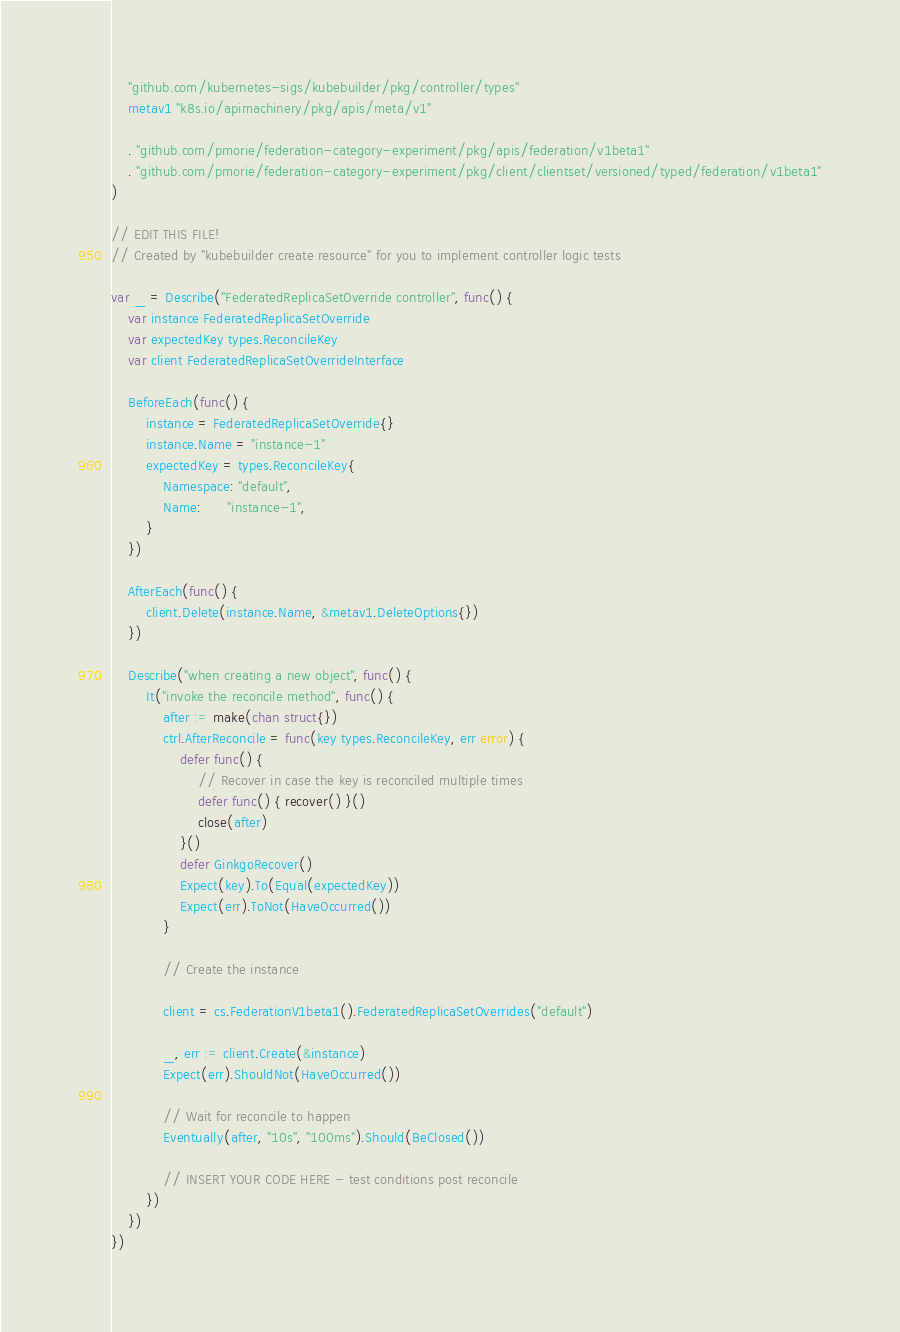Convert code to text. <code><loc_0><loc_0><loc_500><loc_500><_Go_>	"github.com/kubernetes-sigs/kubebuilder/pkg/controller/types"
	metav1 "k8s.io/apimachinery/pkg/apis/meta/v1"

	. "github.com/pmorie/federation-category-experiment/pkg/apis/federation/v1beta1"
	. "github.com/pmorie/federation-category-experiment/pkg/client/clientset/versioned/typed/federation/v1beta1"
)

// EDIT THIS FILE!
// Created by "kubebuilder create resource" for you to implement controller logic tests

var _ = Describe("FederatedReplicaSetOverride controller", func() {
	var instance FederatedReplicaSetOverride
	var expectedKey types.ReconcileKey
	var client FederatedReplicaSetOverrideInterface

	BeforeEach(func() {
		instance = FederatedReplicaSetOverride{}
		instance.Name = "instance-1"
		expectedKey = types.ReconcileKey{
			Namespace: "default",
			Name:      "instance-1",
		}
	})

	AfterEach(func() {
		client.Delete(instance.Name, &metav1.DeleteOptions{})
	})

	Describe("when creating a new object", func() {
		It("invoke the reconcile method", func() {
			after := make(chan struct{})
			ctrl.AfterReconcile = func(key types.ReconcileKey, err error) {
				defer func() {
					// Recover in case the key is reconciled multiple times
					defer func() { recover() }()
					close(after)
				}()
				defer GinkgoRecover()
				Expect(key).To(Equal(expectedKey))
				Expect(err).ToNot(HaveOccurred())
			}

			// Create the instance

			client = cs.FederationV1beta1().FederatedReplicaSetOverrides("default")

			_, err := client.Create(&instance)
			Expect(err).ShouldNot(HaveOccurred())

			// Wait for reconcile to happen
			Eventually(after, "10s", "100ms").Should(BeClosed())

			// INSERT YOUR CODE HERE - test conditions post reconcile
		})
	})
})
</code> 